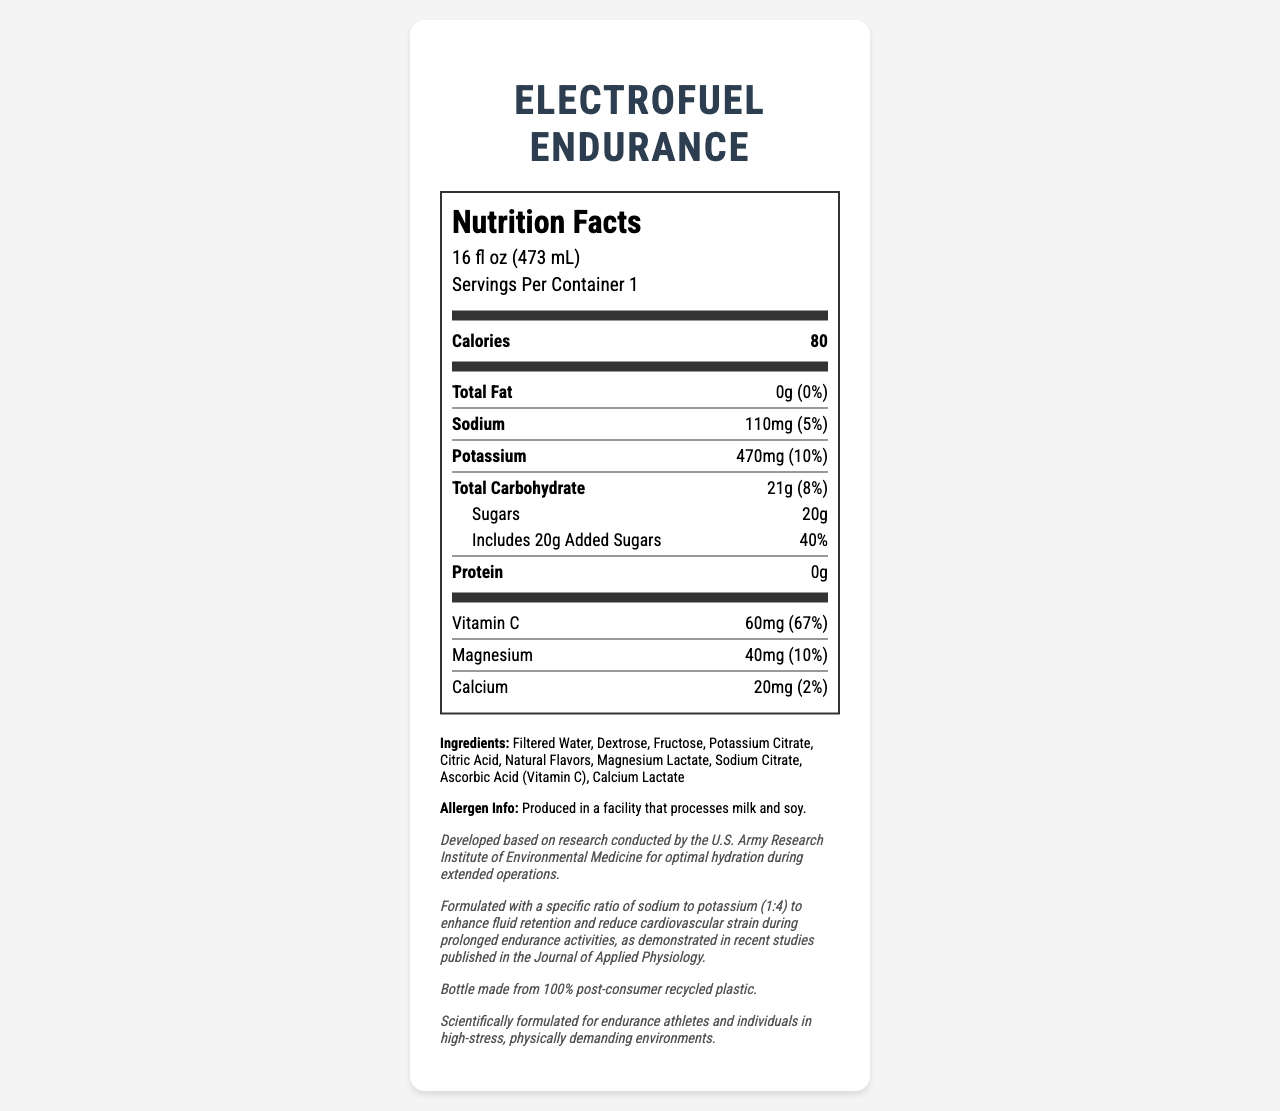What is the serving size for ElectroFuel Endurance? The serving size is listed at the top of the nutrition label under "Nutrition Facts".
Answer: 16 fl oz (473 mL) What is the total number of calories per serving? The number of calories per serving is displayed prominently on the nutrition label.
Answer: 80 How much potassium is in one serving of ElectroFuel Endurance? The potassium content is listed on the nutrition label under "Potassium".
Answer: 470mg What is the source of vitamin C in this drink? The source of vitamin C can be found in the ingredients list, which mentions "Ascorbic Acid (Vitamin C)".
Answer: Ascorbic Acid (Vitamin C) What is the daily value percentage of added sugars in one serving? The daily value percentage for added sugars is listed under the sugars section on the nutrition label.
Answer: 40% Which nutrient has the highest daily value percentage? 
A. Calcium
B. Magnesium
C. Vitamin C
D. Potassium Vitamin C has the highest daily value percentage at 67%, as listed on the nutrition label.
Answer: C What is the ratio of sodium to potassium in ElectroFuel Endurance?
A. 1:1
B. 1:2
C. 1:4
D. 4:1 The research insight notes that the drink is formulated with a specific sodium to potassium ratio of 1:4.
Answer: C Is ElectroFuel Endurance high in protein? The nutrition label shows that the protein content is 0g, indicating that it is not high in protein.
Answer: No Summarize the main purpose and features of ElectroFuel Endurance. The summary encompasses the key aspects of the beverage, highlighting its nutritional profile, target audience, military relevance, and sustainability features.
Answer: ElectroFuel Endurance is a low-sodium, high-potassium sports drink formulated specifically for endurance athletes. It contains 80 calories, 110mg of sodium, and 470mg of potassium per serving. The drink also includes significant amounts of vitamin C and magnesium, making it an optimal hydration solution developed based on military research. Additionally, the bottle is sustainably made from 100% post-consumer recycled plastic. Can children under the age of 10 consume ElectroFuel Endurance safely? The document does not provide details about the suitability of the drink for children under the age of 10.
Answer: Not enough information What is the daily value percentage of magnesium in one serving? The daily value percentage for magnesium is listed on the nutrition label under "Magnesium".
Answer: 10% In what type of facility is ElectroFuel Endurance produced? The allergen information section of the document specifies that it is produced in a facility that processes milk and soy.
Answer: A facility that processes milk and soy How many grams of total carbohydrate are in one serving? The total carbohydrate content is listed on the nutrition label as 21g per serving.
Answer: 21g 